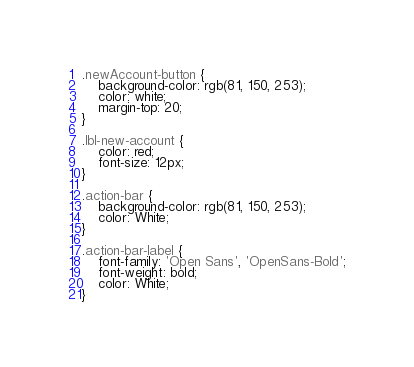<code> <loc_0><loc_0><loc_500><loc_500><_CSS_>.newAccount-button {
    background-color: rgb(81, 150, 253);
    color: white;
    margin-top: 20;
}

.lbl-new-account {
    color: red;
    font-size: 12px;
}

.action-bar {
    background-color: rgb(81, 150, 253);
    color: White;
}

.action-bar-label {
    font-family: 'Open Sans', 'OpenSans-Bold';
    font-weight: bold;
    color: White;
}</code> 